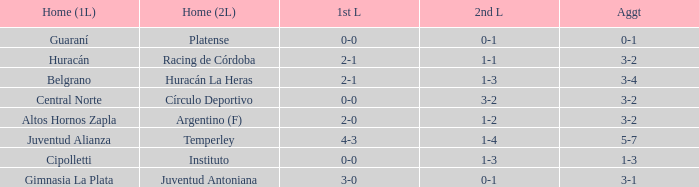Which team had their first leg at home and finished with a total score of 3-4? Belgrano. 